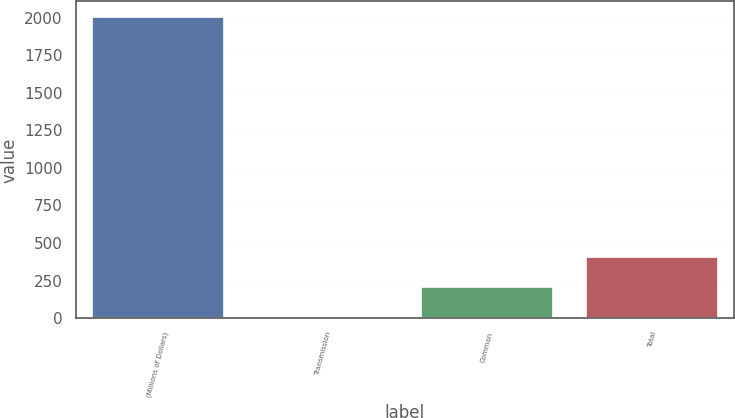Convert chart. <chart><loc_0><loc_0><loc_500><loc_500><bar_chart><fcel>(Millions of Dollars)<fcel>Transmission<fcel>Common<fcel>Total<nl><fcel>2007<fcel>6<fcel>206.1<fcel>406.2<nl></chart> 